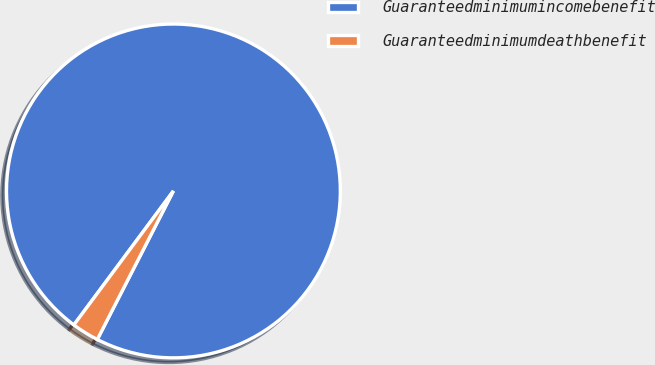Convert chart. <chart><loc_0><loc_0><loc_500><loc_500><pie_chart><fcel>Guaranteedminimumincomebenefit<fcel>Guaranteedminimumdeathbenefit<nl><fcel>97.37%<fcel>2.63%<nl></chart> 